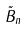<formula> <loc_0><loc_0><loc_500><loc_500>\tilde { B } _ { n }</formula> 